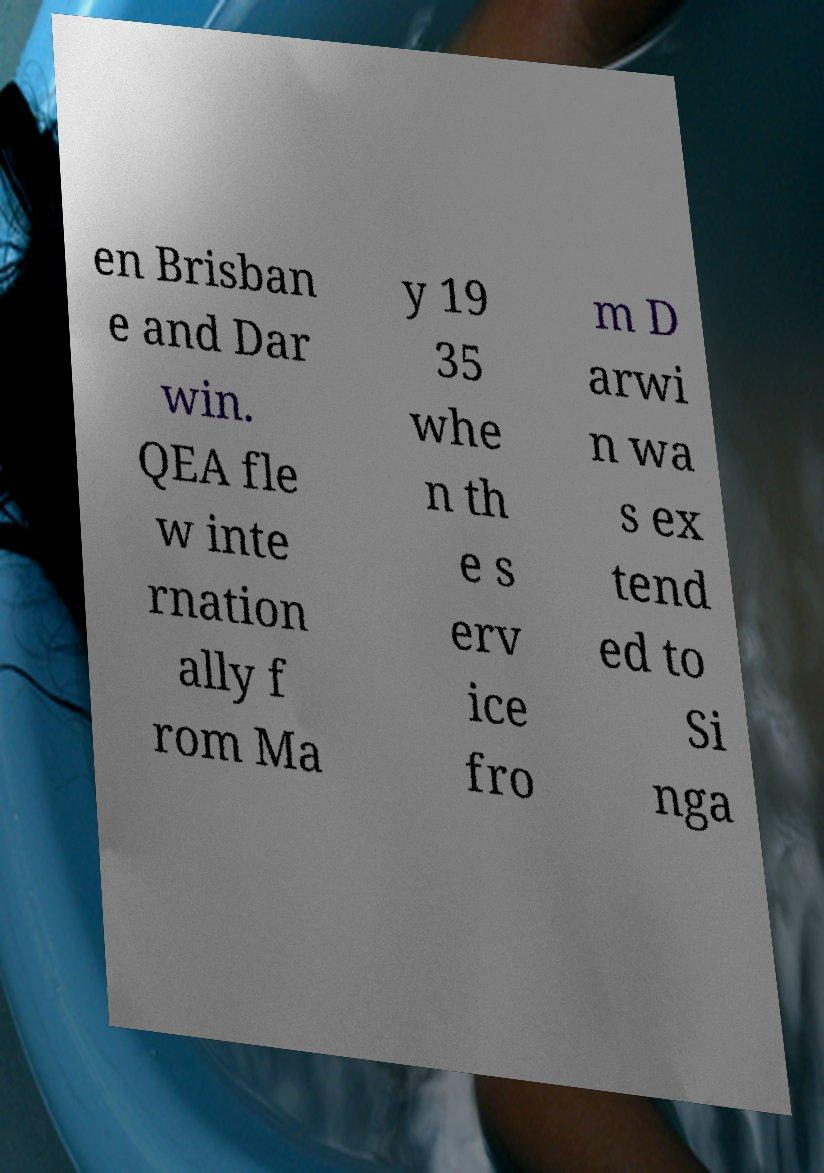There's text embedded in this image that I need extracted. Can you transcribe it verbatim? en Brisban e and Dar win. QEA fle w inte rnation ally f rom Ma y 19 35 whe n th e s erv ice fro m D arwi n wa s ex tend ed to Si nga 